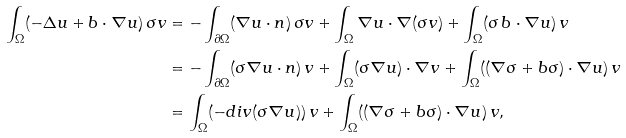Convert formula to latex. <formula><loc_0><loc_0><loc_500><loc_500>\int _ { \Omega } ( - \Delta u + b \cdot \nabla u ) \, \sigma v & = - \int _ { \partial \Omega } ( \nabla u \cdot n ) \, \sigma v + \int _ { \Omega } \nabla u \cdot \nabla ( \sigma v ) + \int _ { \Omega } ( \sigma \, b \cdot \nabla u ) \, v \\ & = - \int _ { \partial \Omega } ( \sigma \nabla u \cdot n ) \, v + \int _ { \Omega } ( \sigma \nabla u ) \cdot \nabla v + \int _ { \Omega } ( ( \nabla \sigma + b \sigma ) \cdot \nabla u ) \, v \\ & = \int _ { \Omega } ( - d i v ( \sigma \nabla u ) ) \, v + \int _ { \Omega } ( ( \nabla \sigma + b \sigma ) \cdot \nabla u ) \, v ,</formula> 